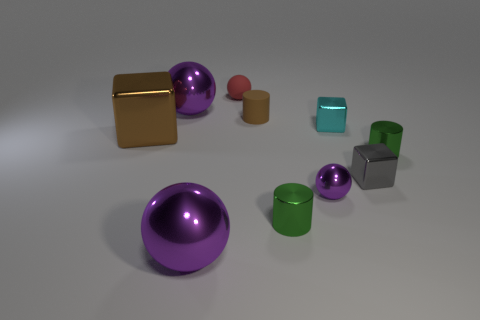There is a metallic block that is to the left of the matte cylinder; is it the same size as the rubber cylinder?
Offer a very short reply. No. How many other objects are there of the same size as the gray metallic block?
Your answer should be compact. 6. Is there a tiny red matte ball?
Your answer should be compact. Yes. There is a shiny block left of the small sphere right of the tiny rubber cylinder; what is its size?
Your answer should be very brief. Large. There is a cube that is in front of the big brown block; does it have the same color as the matte object in front of the red matte sphere?
Your answer should be compact. No. There is a ball that is both behind the big brown metallic object and in front of the tiny red sphere; what is its color?
Provide a short and direct response. Purple. How many other things are the same shape as the tiny red rubber object?
Offer a very short reply. 3. What color is the other block that is the same size as the gray cube?
Your answer should be very brief. Cyan. The big metallic thing behind the brown cylinder is what color?
Provide a short and direct response. Purple. There is a tiny green cylinder that is to the right of the cyan object; is there a small gray metallic cube on the right side of it?
Give a very brief answer. No. 